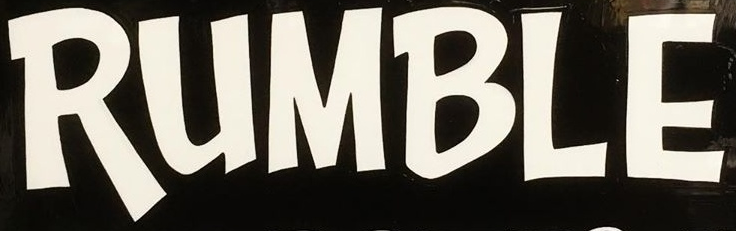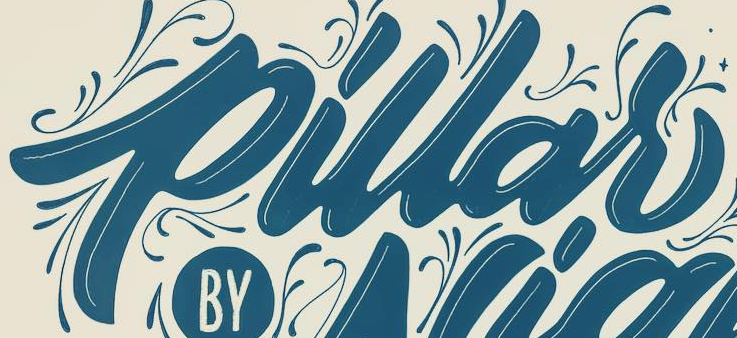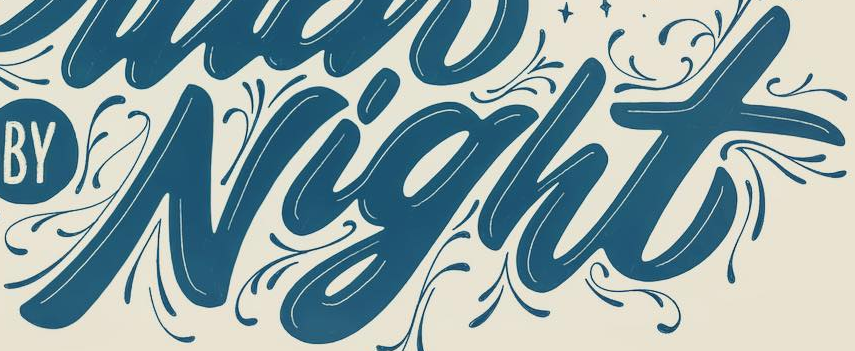Identify the words shown in these images in order, separated by a semicolon. RUMBLE; pillar; Night 